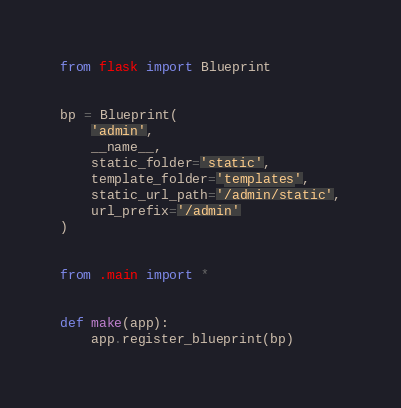<code> <loc_0><loc_0><loc_500><loc_500><_Python_>from flask import Blueprint


bp = Blueprint(
    'admin',
    __name__,
    static_folder='static',
    template_folder='templates',
    static_url_path='/admin/static',
    url_prefix='/admin'
)


from .main import *


def make(app):
    app.register_blueprint(bp)
</code> 